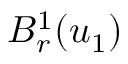Convert formula to latex. <formula><loc_0><loc_0><loc_500><loc_500>B _ { r } ^ { 1 } ( u _ { 1 } )</formula> 